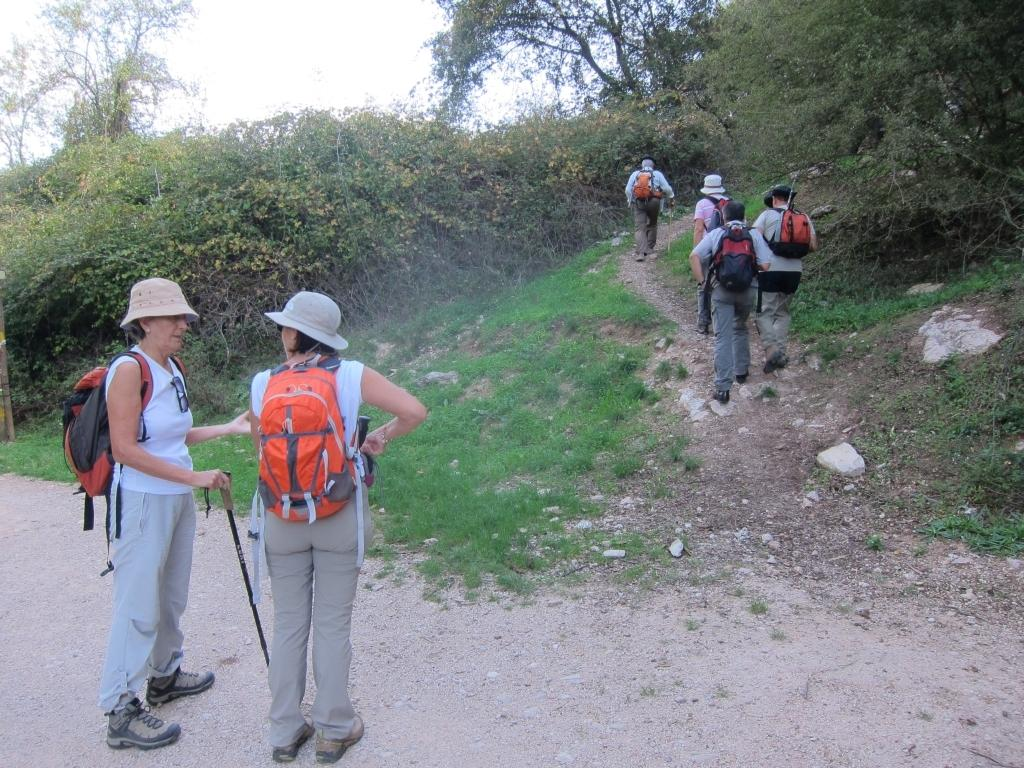What are the people in the image doing? The people in the image are standing and walking. What are the people holding in the image? The people are holding sticks. What type of terrain is visible in the image? There is grass visible in the image. What can be seen in the background of the image? There are trees in the background of the image. What is visible in the sky in the image? There are clouds in the sky, and the sky is visible in the image. What type of list can be seen in the image? There is no list present in the image. What pets are accompanying the people in the image? There are no pets visible in the image. 